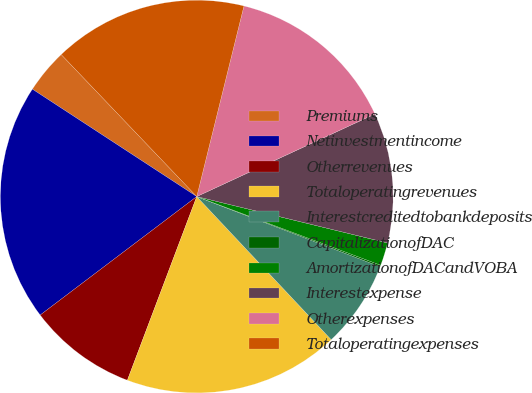Convert chart to OTSL. <chart><loc_0><loc_0><loc_500><loc_500><pie_chart><fcel>Premiums<fcel>Netinvestmentincome<fcel>Otherrevenues<fcel>Totaloperatingrevenues<fcel>Interestcreditedtobankdeposits<fcel>CapitalizationofDAC<fcel>AmortizationofDACandVOBA<fcel>Interestexpense<fcel>Otherexpenses<fcel>Totaloperatingexpenses<nl><fcel>3.66%<fcel>19.52%<fcel>8.94%<fcel>17.75%<fcel>7.18%<fcel>0.13%<fcel>1.89%<fcel>10.7%<fcel>14.23%<fcel>15.99%<nl></chart> 